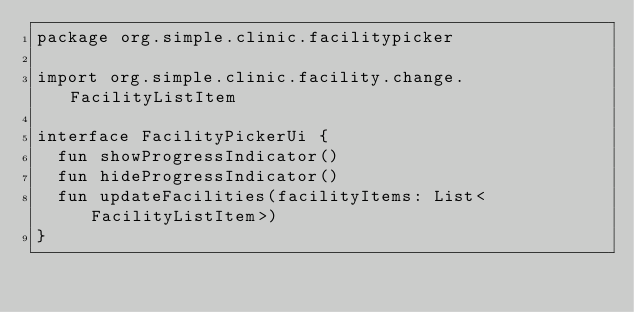Convert code to text. <code><loc_0><loc_0><loc_500><loc_500><_Kotlin_>package org.simple.clinic.facilitypicker

import org.simple.clinic.facility.change.FacilityListItem

interface FacilityPickerUi {
  fun showProgressIndicator()
  fun hideProgressIndicator()
  fun updateFacilities(facilityItems: List<FacilityListItem>)
}
</code> 